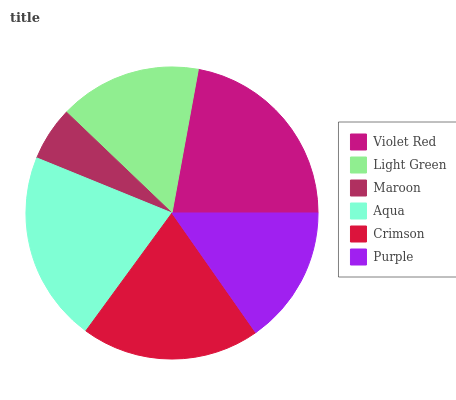Is Maroon the minimum?
Answer yes or no. Yes. Is Violet Red the maximum?
Answer yes or no. Yes. Is Light Green the minimum?
Answer yes or no. No. Is Light Green the maximum?
Answer yes or no. No. Is Violet Red greater than Light Green?
Answer yes or no. Yes. Is Light Green less than Violet Red?
Answer yes or no. Yes. Is Light Green greater than Violet Red?
Answer yes or no. No. Is Violet Red less than Light Green?
Answer yes or no. No. Is Crimson the high median?
Answer yes or no. Yes. Is Light Green the low median?
Answer yes or no. Yes. Is Purple the high median?
Answer yes or no. No. Is Crimson the low median?
Answer yes or no. No. 